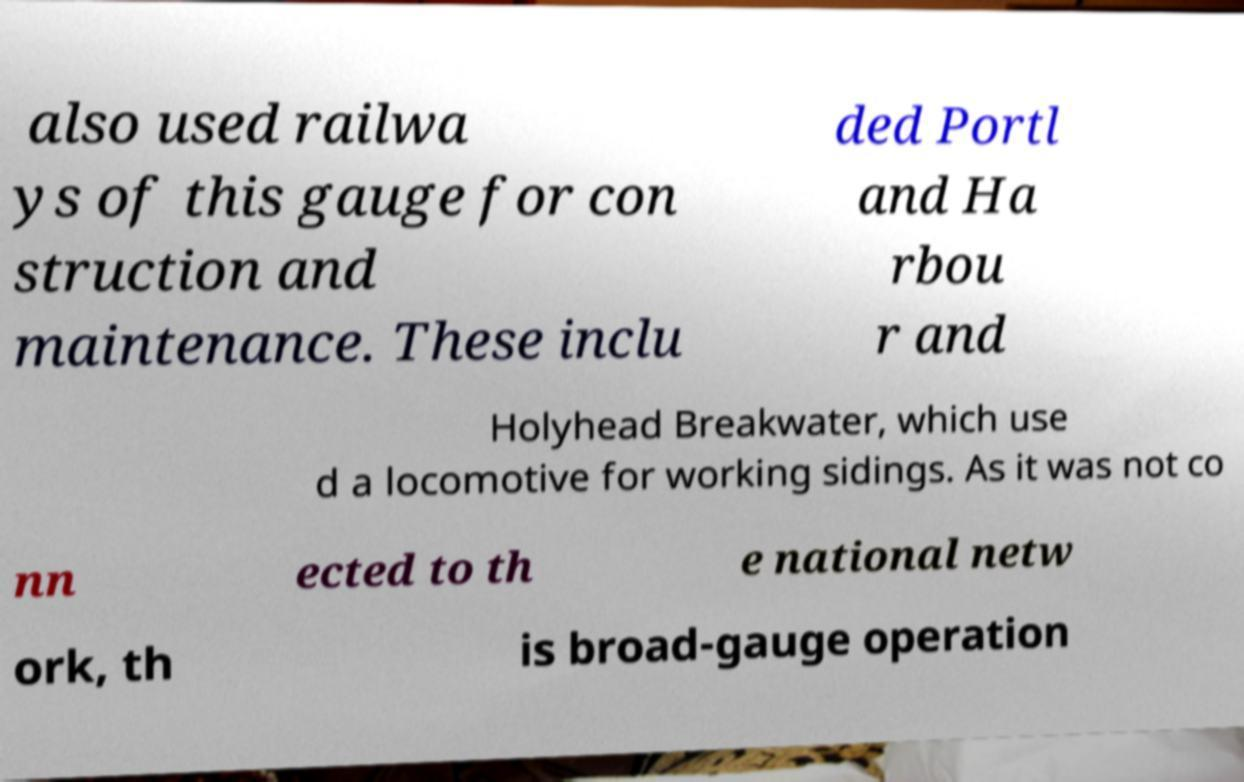There's text embedded in this image that I need extracted. Can you transcribe it verbatim? also used railwa ys of this gauge for con struction and maintenance. These inclu ded Portl and Ha rbou r and Holyhead Breakwater, which use d a locomotive for working sidings. As it was not co nn ected to th e national netw ork, th is broad-gauge operation 